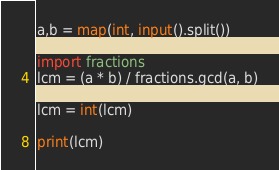Convert code to text. <code><loc_0><loc_0><loc_500><loc_500><_Python_>a,b = map(int, input().split())

import fractions
lcm = (a * b) / fractions.gcd(a, b)

lcm = int(lcm)

print(lcm)</code> 